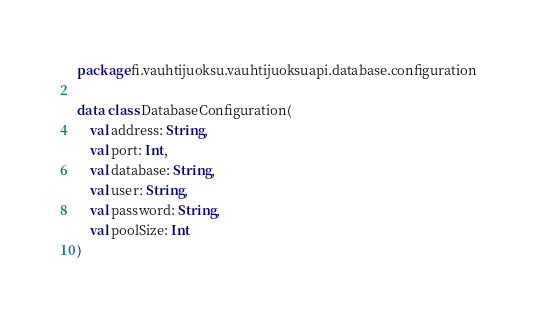<code> <loc_0><loc_0><loc_500><loc_500><_Kotlin_>package fi.vauhtijuoksu.vauhtijuoksuapi.database.configuration

data class DatabaseConfiguration(
    val address: String,
    val port: Int,
    val database: String,
    val user: String,
    val password: String,
    val poolSize: Int
)
</code> 